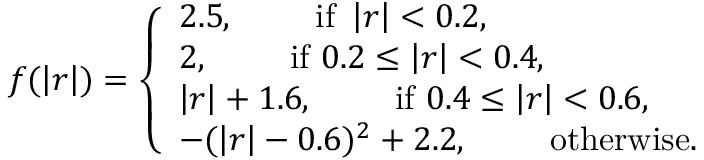Convert formula to latex. <formula><loc_0><loc_0><loc_500><loc_500>f ( \left | r \right | ) = \left \{ \begin{array} { l l } { 2 . 5 , \quad i f \ \left | r \right | < 0 . 2 , } \\ { 2 , \quad i f \ 0 . 2 \leq \left | r \right | < 0 . 4 , } \\ { \left | r \right | + 1 . 6 , \quad i f \ 0 . 4 \leq \left | r \right | < 0 . 6 , } \\ { - ( \left | r \right | - 0 . 6 ) ^ { 2 } + 2 . 2 , \quad o t h e r w i s e . } \end{array}</formula> 